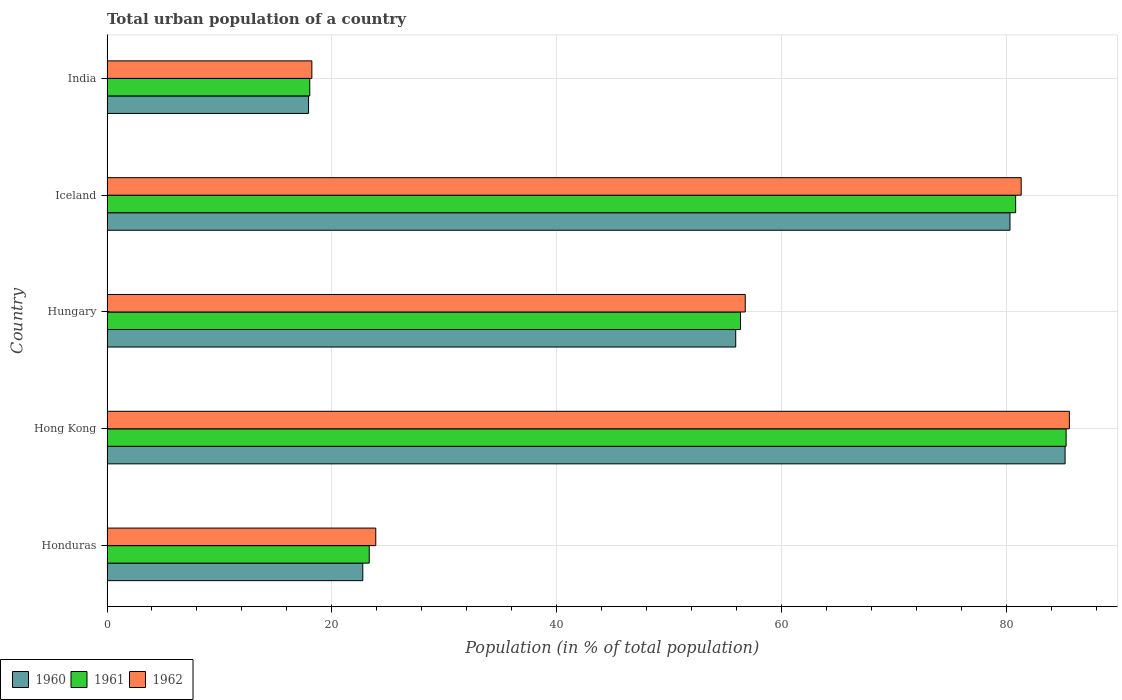Are the number of bars on each tick of the Y-axis equal?
Your answer should be very brief. Yes. How many bars are there on the 4th tick from the bottom?
Provide a succinct answer. 3. What is the label of the 4th group of bars from the top?
Your answer should be compact. Hong Kong. What is the urban population in 1960 in Hungary?
Your answer should be compact. 55.91. Across all countries, what is the maximum urban population in 1962?
Keep it short and to the point. 85.58. Across all countries, what is the minimum urban population in 1960?
Your answer should be compact. 17.92. In which country was the urban population in 1960 maximum?
Your answer should be very brief. Hong Kong. What is the total urban population in 1961 in the graph?
Offer a very short reply. 263.78. What is the difference between the urban population in 1961 in Honduras and that in Iceland?
Give a very brief answer. -57.48. What is the difference between the urban population in 1962 in Honduras and the urban population in 1960 in Hungary?
Make the answer very short. -32.01. What is the average urban population in 1960 per country?
Offer a very short reply. 52.42. What is the difference between the urban population in 1960 and urban population in 1961 in Hungary?
Give a very brief answer. -0.42. What is the ratio of the urban population in 1962 in Hong Kong to that in Iceland?
Provide a short and direct response. 1.05. Is the urban population in 1962 in Honduras less than that in Iceland?
Your response must be concise. Yes. What is the difference between the highest and the second highest urban population in 1961?
Ensure brevity in your answer.  4.49. What is the difference between the highest and the lowest urban population in 1961?
Offer a very short reply. 67.26. Is the sum of the urban population in 1961 in Hong Kong and Hungary greater than the maximum urban population in 1962 across all countries?
Your answer should be compact. Yes. What does the 2nd bar from the top in Hong Kong represents?
Keep it short and to the point. 1961. Is it the case that in every country, the sum of the urban population in 1962 and urban population in 1961 is greater than the urban population in 1960?
Offer a very short reply. Yes. How many bars are there?
Provide a short and direct response. 15. What is the difference between two consecutive major ticks on the X-axis?
Your answer should be very brief. 20. Are the values on the major ticks of X-axis written in scientific E-notation?
Ensure brevity in your answer.  No. Does the graph contain grids?
Your answer should be very brief. Yes. How many legend labels are there?
Your answer should be compact. 3. How are the legend labels stacked?
Your response must be concise. Horizontal. What is the title of the graph?
Keep it short and to the point. Total urban population of a country. What is the label or title of the X-axis?
Make the answer very short. Population (in % of total population). What is the label or title of the Y-axis?
Your answer should be compact. Country. What is the Population (in % of total population) in 1960 in Honduras?
Offer a terse response. 22.75. What is the Population (in % of total population) in 1961 in Honduras?
Keep it short and to the point. 23.32. What is the Population (in % of total population) in 1962 in Honduras?
Make the answer very short. 23.9. What is the Population (in % of total population) in 1960 in Hong Kong?
Keep it short and to the point. 85.2. What is the Population (in % of total population) of 1961 in Hong Kong?
Keep it short and to the point. 85.29. What is the Population (in % of total population) of 1962 in Hong Kong?
Give a very brief answer. 85.58. What is the Population (in % of total population) of 1960 in Hungary?
Provide a short and direct response. 55.91. What is the Population (in % of total population) of 1961 in Hungary?
Ensure brevity in your answer.  56.34. What is the Population (in % of total population) in 1962 in Hungary?
Provide a short and direct response. 56.76. What is the Population (in % of total population) of 1960 in Iceland?
Offer a terse response. 80.3. What is the Population (in % of total population) of 1961 in Iceland?
Provide a short and direct response. 80.8. What is the Population (in % of total population) of 1962 in Iceland?
Provide a short and direct response. 81.3. What is the Population (in % of total population) of 1960 in India?
Your response must be concise. 17.92. What is the Population (in % of total population) of 1961 in India?
Provide a short and direct response. 18.03. What is the Population (in % of total population) in 1962 in India?
Offer a terse response. 18.22. Across all countries, what is the maximum Population (in % of total population) in 1960?
Offer a terse response. 85.2. Across all countries, what is the maximum Population (in % of total population) of 1961?
Your response must be concise. 85.29. Across all countries, what is the maximum Population (in % of total population) of 1962?
Provide a succinct answer. 85.58. Across all countries, what is the minimum Population (in % of total population) of 1960?
Keep it short and to the point. 17.92. Across all countries, what is the minimum Population (in % of total population) of 1961?
Offer a very short reply. 18.03. Across all countries, what is the minimum Population (in % of total population) of 1962?
Offer a terse response. 18.22. What is the total Population (in % of total population) in 1960 in the graph?
Make the answer very short. 262.08. What is the total Population (in % of total population) of 1961 in the graph?
Keep it short and to the point. 263.78. What is the total Population (in % of total population) in 1962 in the graph?
Offer a terse response. 265.75. What is the difference between the Population (in % of total population) of 1960 in Honduras and that in Hong Kong?
Provide a succinct answer. -62.45. What is the difference between the Population (in % of total population) of 1961 in Honduras and that in Hong Kong?
Provide a succinct answer. -61.98. What is the difference between the Population (in % of total population) of 1962 in Honduras and that in Hong Kong?
Make the answer very short. -61.68. What is the difference between the Population (in % of total population) in 1960 in Honduras and that in Hungary?
Keep it short and to the point. -33.16. What is the difference between the Population (in % of total population) in 1961 in Honduras and that in Hungary?
Your answer should be very brief. -33.02. What is the difference between the Population (in % of total population) in 1962 in Honduras and that in Hungary?
Provide a succinct answer. -32.86. What is the difference between the Population (in % of total population) in 1960 in Honduras and that in Iceland?
Offer a terse response. -57.55. What is the difference between the Population (in % of total population) in 1961 in Honduras and that in Iceland?
Provide a short and direct response. -57.48. What is the difference between the Population (in % of total population) in 1962 in Honduras and that in Iceland?
Your answer should be compact. -57.4. What is the difference between the Population (in % of total population) of 1960 in Honduras and that in India?
Your answer should be compact. 4.82. What is the difference between the Population (in % of total population) of 1961 in Honduras and that in India?
Your answer should be compact. 5.29. What is the difference between the Population (in % of total population) in 1962 in Honduras and that in India?
Your answer should be compact. 5.68. What is the difference between the Population (in % of total population) of 1960 in Hong Kong and that in Hungary?
Make the answer very short. 29.29. What is the difference between the Population (in % of total population) of 1961 in Hong Kong and that in Hungary?
Keep it short and to the point. 28.96. What is the difference between the Population (in % of total population) in 1962 in Hong Kong and that in Hungary?
Your response must be concise. 28.82. What is the difference between the Population (in % of total population) in 1961 in Hong Kong and that in Iceland?
Your response must be concise. 4.49. What is the difference between the Population (in % of total population) in 1962 in Hong Kong and that in Iceland?
Provide a succinct answer. 4.29. What is the difference between the Population (in % of total population) in 1960 in Hong Kong and that in India?
Give a very brief answer. 67.28. What is the difference between the Population (in % of total population) in 1961 in Hong Kong and that in India?
Give a very brief answer. 67.26. What is the difference between the Population (in % of total population) in 1962 in Hong Kong and that in India?
Give a very brief answer. 67.36. What is the difference between the Population (in % of total population) of 1960 in Hungary and that in Iceland?
Provide a succinct answer. -24.39. What is the difference between the Population (in % of total population) in 1961 in Hungary and that in Iceland?
Ensure brevity in your answer.  -24.47. What is the difference between the Population (in % of total population) in 1962 in Hungary and that in Iceland?
Keep it short and to the point. -24.54. What is the difference between the Population (in % of total population) of 1960 in Hungary and that in India?
Offer a terse response. 37.99. What is the difference between the Population (in % of total population) of 1961 in Hungary and that in India?
Ensure brevity in your answer.  38.3. What is the difference between the Population (in % of total population) of 1962 in Hungary and that in India?
Provide a succinct answer. 38.54. What is the difference between the Population (in % of total population) in 1960 in Iceland and that in India?
Ensure brevity in your answer.  62.38. What is the difference between the Population (in % of total population) of 1961 in Iceland and that in India?
Offer a terse response. 62.77. What is the difference between the Population (in % of total population) in 1962 in Iceland and that in India?
Provide a succinct answer. 63.08. What is the difference between the Population (in % of total population) of 1960 in Honduras and the Population (in % of total population) of 1961 in Hong Kong?
Your answer should be very brief. -62.55. What is the difference between the Population (in % of total population) of 1960 in Honduras and the Population (in % of total population) of 1962 in Hong Kong?
Your answer should be very brief. -62.84. What is the difference between the Population (in % of total population) in 1961 in Honduras and the Population (in % of total population) in 1962 in Hong Kong?
Make the answer very short. -62.26. What is the difference between the Population (in % of total population) of 1960 in Honduras and the Population (in % of total population) of 1961 in Hungary?
Ensure brevity in your answer.  -33.59. What is the difference between the Population (in % of total population) in 1960 in Honduras and the Population (in % of total population) in 1962 in Hungary?
Make the answer very short. -34.01. What is the difference between the Population (in % of total population) of 1961 in Honduras and the Population (in % of total population) of 1962 in Hungary?
Your response must be concise. -33.44. What is the difference between the Population (in % of total population) of 1960 in Honduras and the Population (in % of total population) of 1961 in Iceland?
Offer a very short reply. -58.06. What is the difference between the Population (in % of total population) in 1960 in Honduras and the Population (in % of total population) in 1962 in Iceland?
Provide a succinct answer. -58.55. What is the difference between the Population (in % of total population) of 1961 in Honduras and the Population (in % of total population) of 1962 in Iceland?
Provide a succinct answer. -57.98. What is the difference between the Population (in % of total population) in 1960 in Honduras and the Population (in % of total population) in 1961 in India?
Give a very brief answer. 4.71. What is the difference between the Population (in % of total population) of 1960 in Honduras and the Population (in % of total population) of 1962 in India?
Keep it short and to the point. 4.53. What is the difference between the Population (in % of total population) of 1960 in Hong Kong and the Population (in % of total population) of 1961 in Hungary?
Give a very brief answer. 28.86. What is the difference between the Population (in % of total population) in 1960 in Hong Kong and the Population (in % of total population) in 1962 in Hungary?
Ensure brevity in your answer.  28.44. What is the difference between the Population (in % of total population) of 1961 in Hong Kong and the Population (in % of total population) of 1962 in Hungary?
Give a very brief answer. 28.54. What is the difference between the Population (in % of total population) in 1960 in Hong Kong and the Population (in % of total population) in 1961 in Iceland?
Your answer should be compact. 4.4. What is the difference between the Population (in % of total population) in 1960 in Hong Kong and the Population (in % of total population) in 1962 in Iceland?
Keep it short and to the point. 3.9. What is the difference between the Population (in % of total population) of 1961 in Hong Kong and the Population (in % of total population) of 1962 in Iceland?
Offer a very short reply. 4. What is the difference between the Population (in % of total population) in 1960 in Hong Kong and the Population (in % of total population) in 1961 in India?
Offer a terse response. 67.17. What is the difference between the Population (in % of total population) of 1960 in Hong Kong and the Population (in % of total population) of 1962 in India?
Provide a short and direct response. 66.98. What is the difference between the Population (in % of total population) of 1961 in Hong Kong and the Population (in % of total population) of 1962 in India?
Ensure brevity in your answer.  67.08. What is the difference between the Population (in % of total population) of 1960 in Hungary and the Population (in % of total population) of 1961 in Iceland?
Offer a very short reply. -24.89. What is the difference between the Population (in % of total population) in 1960 in Hungary and the Population (in % of total population) in 1962 in Iceland?
Provide a succinct answer. -25.39. What is the difference between the Population (in % of total population) of 1961 in Hungary and the Population (in % of total population) of 1962 in Iceland?
Keep it short and to the point. -24.96. What is the difference between the Population (in % of total population) of 1960 in Hungary and the Population (in % of total population) of 1961 in India?
Provide a short and direct response. 37.88. What is the difference between the Population (in % of total population) of 1960 in Hungary and the Population (in % of total population) of 1962 in India?
Your answer should be very brief. 37.69. What is the difference between the Population (in % of total population) in 1961 in Hungary and the Population (in % of total population) in 1962 in India?
Your answer should be compact. 38.12. What is the difference between the Population (in % of total population) in 1960 in Iceland and the Population (in % of total population) in 1961 in India?
Offer a very short reply. 62.27. What is the difference between the Population (in % of total population) of 1960 in Iceland and the Population (in % of total population) of 1962 in India?
Your answer should be very brief. 62.08. What is the difference between the Population (in % of total population) in 1961 in Iceland and the Population (in % of total population) in 1962 in India?
Keep it short and to the point. 62.59. What is the average Population (in % of total population) in 1960 per country?
Ensure brevity in your answer.  52.42. What is the average Population (in % of total population) of 1961 per country?
Your answer should be compact. 52.76. What is the average Population (in % of total population) in 1962 per country?
Offer a terse response. 53.15. What is the difference between the Population (in % of total population) in 1960 and Population (in % of total population) in 1961 in Honduras?
Keep it short and to the point. -0.57. What is the difference between the Population (in % of total population) in 1960 and Population (in % of total population) in 1962 in Honduras?
Make the answer very short. -1.15. What is the difference between the Population (in % of total population) of 1961 and Population (in % of total population) of 1962 in Honduras?
Your response must be concise. -0.58. What is the difference between the Population (in % of total population) of 1960 and Population (in % of total population) of 1961 in Hong Kong?
Your response must be concise. -0.09. What is the difference between the Population (in % of total population) of 1960 and Population (in % of total population) of 1962 in Hong Kong?
Your answer should be very brief. -0.38. What is the difference between the Population (in % of total population) of 1961 and Population (in % of total population) of 1962 in Hong Kong?
Your answer should be compact. -0.29. What is the difference between the Population (in % of total population) in 1960 and Population (in % of total population) in 1961 in Hungary?
Provide a short and direct response. -0.42. What is the difference between the Population (in % of total population) in 1960 and Population (in % of total population) in 1962 in Hungary?
Provide a short and direct response. -0.85. What is the difference between the Population (in % of total population) in 1961 and Population (in % of total population) in 1962 in Hungary?
Keep it short and to the point. -0.42. What is the difference between the Population (in % of total population) in 1960 and Population (in % of total population) in 1961 in Iceland?
Keep it short and to the point. -0.5. What is the difference between the Population (in % of total population) in 1960 and Population (in % of total population) in 1962 in Iceland?
Provide a succinct answer. -1. What is the difference between the Population (in % of total population) in 1961 and Population (in % of total population) in 1962 in Iceland?
Make the answer very short. -0.49. What is the difference between the Population (in % of total population) in 1960 and Population (in % of total population) in 1961 in India?
Keep it short and to the point. -0.11. What is the difference between the Population (in % of total population) in 1960 and Population (in % of total population) in 1962 in India?
Ensure brevity in your answer.  -0.29. What is the difference between the Population (in % of total population) in 1961 and Population (in % of total population) in 1962 in India?
Your answer should be very brief. -0.19. What is the ratio of the Population (in % of total population) in 1960 in Honduras to that in Hong Kong?
Offer a very short reply. 0.27. What is the ratio of the Population (in % of total population) of 1961 in Honduras to that in Hong Kong?
Keep it short and to the point. 0.27. What is the ratio of the Population (in % of total population) of 1962 in Honduras to that in Hong Kong?
Keep it short and to the point. 0.28. What is the ratio of the Population (in % of total population) in 1960 in Honduras to that in Hungary?
Your response must be concise. 0.41. What is the ratio of the Population (in % of total population) in 1961 in Honduras to that in Hungary?
Make the answer very short. 0.41. What is the ratio of the Population (in % of total population) in 1962 in Honduras to that in Hungary?
Provide a succinct answer. 0.42. What is the ratio of the Population (in % of total population) in 1960 in Honduras to that in Iceland?
Give a very brief answer. 0.28. What is the ratio of the Population (in % of total population) of 1961 in Honduras to that in Iceland?
Your answer should be compact. 0.29. What is the ratio of the Population (in % of total population) in 1962 in Honduras to that in Iceland?
Provide a succinct answer. 0.29. What is the ratio of the Population (in % of total population) of 1960 in Honduras to that in India?
Provide a succinct answer. 1.27. What is the ratio of the Population (in % of total population) in 1961 in Honduras to that in India?
Make the answer very short. 1.29. What is the ratio of the Population (in % of total population) in 1962 in Honduras to that in India?
Keep it short and to the point. 1.31. What is the ratio of the Population (in % of total population) of 1960 in Hong Kong to that in Hungary?
Give a very brief answer. 1.52. What is the ratio of the Population (in % of total population) of 1961 in Hong Kong to that in Hungary?
Give a very brief answer. 1.51. What is the ratio of the Population (in % of total population) in 1962 in Hong Kong to that in Hungary?
Keep it short and to the point. 1.51. What is the ratio of the Population (in % of total population) in 1960 in Hong Kong to that in Iceland?
Provide a succinct answer. 1.06. What is the ratio of the Population (in % of total population) in 1961 in Hong Kong to that in Iceland?
Give a very brief answer. 1.06. What is the ratio of the Population (in % of total population) in 1962 in Hong Kong to that in Iceland?
Ensure brevity in your answer.  1.05. What is the ratio of the Population (in % of total population) of 1960 in Hong Kong to that in India?
Provide a succinct answer. 4.75. What is the ratio of the Population (in % of total population) in 1961 in Hong Kong to that in India?
Provide a succinct answer. 4.73. What is the ratio of the Population (in % of total population) of 1962 in Hong Kong to that in India?
Your answer should be very brief. 4.7. What is the ratio of the Population (in % of total population) of 1960 in Hungary to that in Iceland?
Your response must be concise. 0.7. What is the ratio of the Population (in % of total population) of 1961 in Hungary to that in Iceland?
Your answer should be very brief. 0.7. What is the ratio of the Population (in % of total population) in 1962 in Hungary to that in Iceland?
Offer a terse response. 0.7. What is the ratio of the Population (in % of total population) of 1960 in Hungary to that in India?
Your answer should be very brief. 3.12. What is the ratio of the Population (in % of total population) of 1961 in Hungary to that in India?
Keep it short and to the point. 3.12. What is the ratio of the Population (in % of total population) in 1962 in Hungary to that in India?
Your answer should be compact. 3.12. What is the ratio of the Population (in % of total population) of 1960 in Iceland to that in India?
Your answer should be very brief. 4.48. What is the ratio of the Population (in % of total population) in 1961 in Iceland to that in India?
Provide a succinct answer. 4.48. What is the ratio of the Population (in % of total population) in 1962 in Iceland to that in India?
Provide a succinct answer. 4.46. What is the difference between the highest and the second highest Population (in % of total population) of 1961?
Give a very brief answer. 4.49. What is the difference between the highest and the second highest Population (in % of total population) in 1962?
Your answer should be compact. 4.29. What is the difference between the highest and the lowest Population (in % of total population) in 1960?
Your answer should be compact. 67.28. What is the difference between the highest and the lowest Population (in % of total population) of 1961?
Make the answer very short. 67.26. What is the difference between the highest and the lowest Population (in % of total population) in 1962?
Make the answer very short. 67.36. 